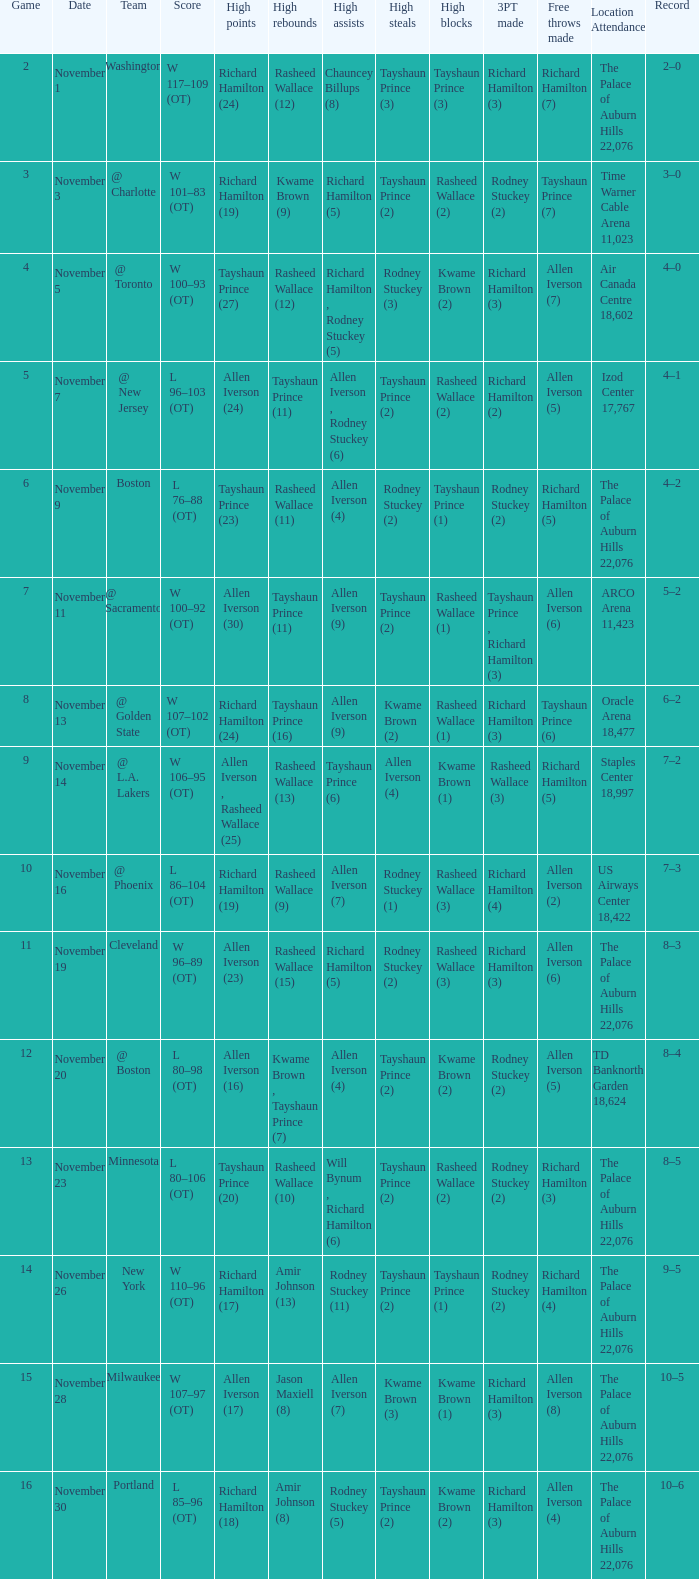What is High Points, when Game is "5"? Allen Iverson (24). 